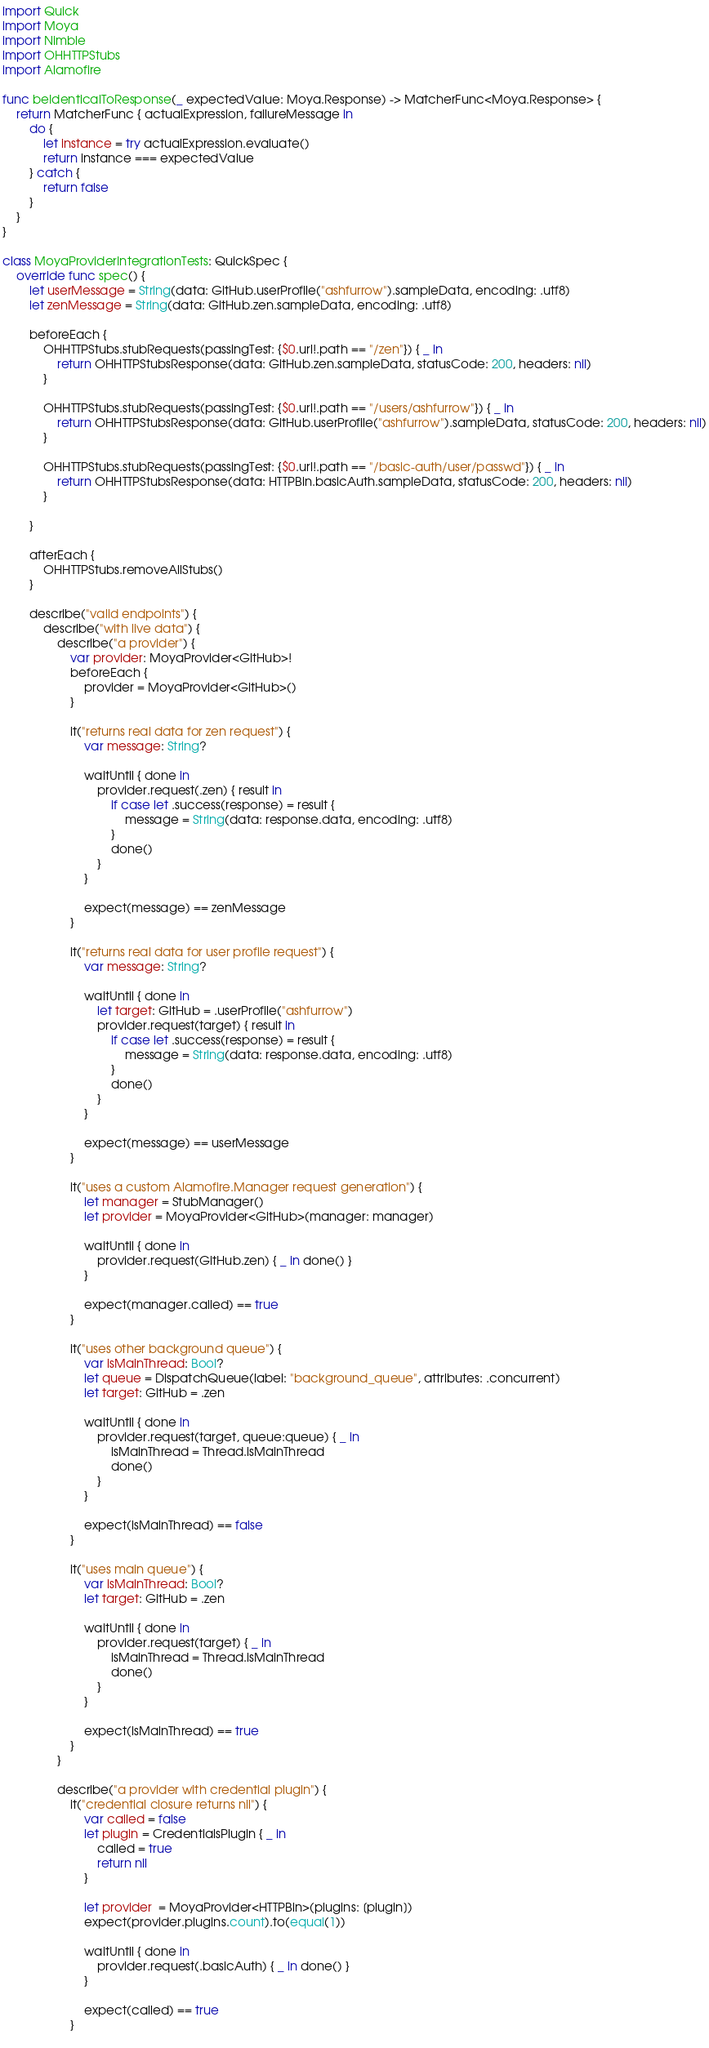<code> <loc_0><loc_0><loc_500><loc_500><_Swift_>import Quick
import Moya
import Nimble
import OHHTTPStubs
import Alamofire

func beIdenticalToResponse(_ expectedValue: Moya.Response) -> MatcherFunc<Moya.Response> {
    return MatcherFunc { actualExpression, failureMessage in
        do {
            let instance = try actualExpression.evaluate()
            return instance === expectedValue
        } catch {
            return false
        }
    }
}

class MoyaProviderIntegrationTests: QuickSpec {
    override func spec() {
        let userMessage = String(data: GitHub.userProfile("ashfurrow").sampleData, encoding: .utf8)
        let zenMessage = String(data: GitHub.zen.sampleData, encoding: .utf8)
        
        beforeEach {
            OHHTTPStubs.stubRequests(passingTest: {$0.url!.path == "/zen"}) { _ in
                return OHHTTPStubsResponse(data: GitHub.zen.sampleData, statusCode: 200, headers: nil)
            }
            
            OHHTTPStubs.stubRequests(passingTest: {$0.url!.path == "/users/ashfurrow"}) { _ in
                return OHHTTPStubsResponse(data: GitHub.userProfile("ashfurrow").sampleData, statusCode: 200, headers: nil)
            }
            
            OHHTTPStubs.stubRequests(passingTest: {$0.url!.path == "/basic-auth/user/passwd"}) { _ in
                return OHHTTPStubsResponse(data: HTTPBin.basicAuth.sampleData, statusCode: 200, headers: nil)
            }
            
        }
        
        afterEach {
            OHHTTPStubs.removeAllStubs()
        }
        
        describe("valid endpoints") {
            describe("with live data") {
                describe("a provider") {
                    var provider: MoyaProvider<GitHub>!
                    beforeEach {
                        provider = MoyaProvider<GitHub>()
                    }
                    
                    it("returns real data for zen request") {
                        var message: String?

                        waitUntil { done in
                            provider.request(.zen) { result in
                                if case let .success(response) = result {
                                    message = String(data: response.data, encoding: .utf8)
                                }
                                done()
                            }
                        }
                        
                        expect(message) == zenMessage
                    }
                    
                    it("returns real data for user profile request") {
                        var message: String?

                        waitUntil { done in
                            let target: GitHub = .userProfile("ashfurrow")
                            provider.request(target) { result in
                                if case let .success(response) = result {
                                    message = String(data: response.data, encoding: .utf8)
                                }
                                done()
                            }
                        }
                        
                        expect(message) == userMessage
                    }

                    it("uses a custom Alamofire.Manager request generation") {
                        let manager = StubManager()
                        let provider = MoyaProvider<GitHub>(manager: manager)

                        waitUntil { done in
                            provider.request(GitHub.zen) { _ in done() }
                        }

                        expect(manager.called) == true
                    }
                    
                    it("uses other background queue") {
                        var isMainThread: Bool?
                        let queue = DispatchQueue(label: "background_queue", attributes: .concurrent)
                        let target: GitHub = .zen
                        
                        waitUntil { done in
                            provider.request(target, queue:queue) { _ in
                                isMainThread = Thread.isMainThread
                                done()
                            }
                        }
                        
                        expect(isMainThread) == false
                    }
                    
                    it("uses main queue") {
                        var isMainThread: Bool?
                        let target: GitHub = .zen
                        
                        waitUntil { done in 
                            provider.request(target) { _ in
                                isMainThread = Thread.isMainThread
                                done()
                            }
                        }
                        
                        expect(isMainThread) == true
                    }
                }
                
                describe("a provider with credential plugin") {
                    it("credential closure returns nil") {
                        var called = false
                        let plugin = CredentialsPlugin { _ in
                            called = true
                            return nil
                        }
                        
                        let provider  = MoyaProvider<HTTPBin>(plugins: [plugin])
                        expect(provider.plugins.count).to(equal(1))

                        waitUntil { done in
                            provider.request(.basicAuth) { _ in done() }
                        }
                        
                        expect(called) == true
                    }
                    </code> 